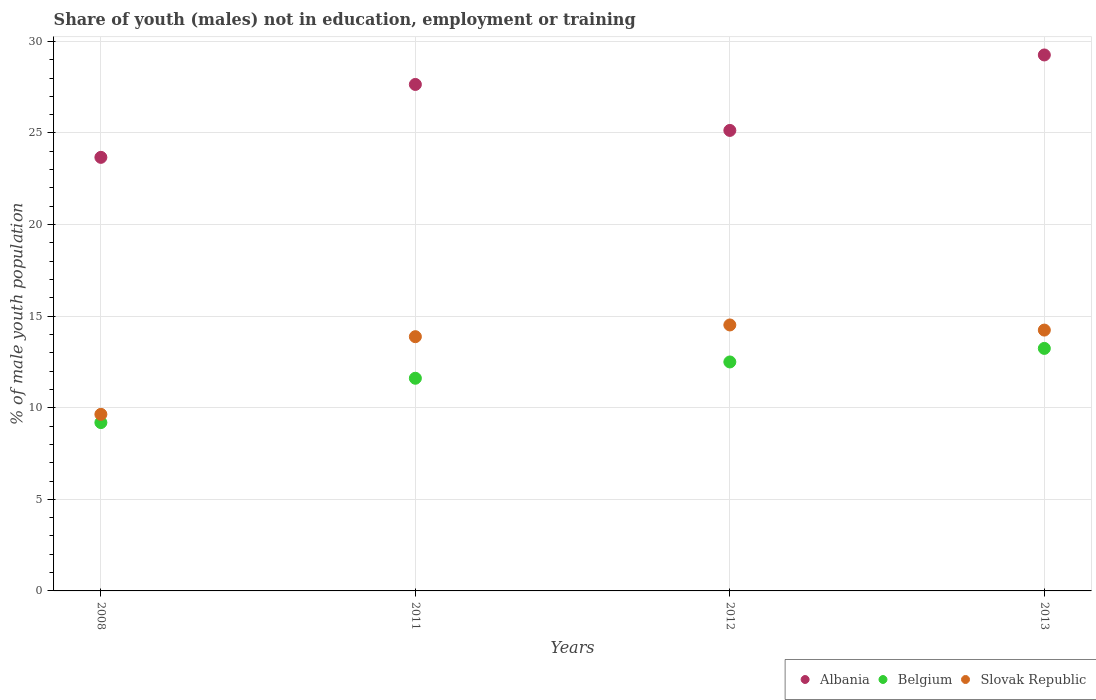How many different coloured dotlines are there?
Your answer should be compact. 3. What is the percentage of unemployed males population in in Slovak Republic in 2013?
Your response must be concise. 14.24. Across all years, what is the maximum percentage of unemployed males population in in Albania?
Keep it short and to the point. 29.26. Across all years, what is the minimum percentage of unemployed males population in in Albania?
Offer a very short reply. 23.67. In which year was the percentage of unemployed males population in in Albania maximum?
Make the answer very short. 2013. In which year was the percentage of unemployed males population in in Slovak Republic minimum?
Your answer should be compact. 2008. What is the total percentage of unemployed males population in in Belgium in the graph?
Your answer should be very brief. 46.54. What is the difference between the percentage of unemployed males population in in Slovak Republic in 2011 and that in 2012?
Make the answer very short. -0.64. What is the difference between the percentage of unemployed males population in in Slovak Republic in 2011 and the percentage of unemployed males population in in Belgium in 2013?
Your answer should be compact. 0.64. What is the average percentage of unemployed males population in in Albania per year?
Offer a terse response. 26.43. In the year 2011, what is the difference between the percentage of unemployed males population in in Albania and percentage of unemployed males population in in Slovak Republic?
Ensure brevity in your answer.  13.77. In how many years, is the percentage of unemployed males population in in Slovak Republic greater than 7 %?
Ensure brevity in your answer.  4. What is the ratio of the percentage of unemployed males population in in Belgium in 2012 to that in 2013?
Make the answer very short. 0.94. What is the difference between the highest and the second highest percentage of unemployed males population in in Belgium?
Make the answer very short. 0.74. What is the difference between the highest and the lowest percentage of unemployed males population in in Belgium?
Provide a short and direct response. 4.05. In how many years, is the percentage of unemployed males population in in Albania greater than the average percentage of unemployed males population in in Albania taken over all years?
Offer a very short reply. 2. Is it the case that in every year, the sum of the percentage of unemployed males population in in Albania and percentage of unemployed males population in in Slovak Republic  is greater than the percentage of unemployed males population in in Belgium?
Your response must be concise. Yes. Does the percentage of unemployed males population in in Albania monotonically increase over the years?
Offer a very short reply. No. How many years are there in the graph?
Keep it short and to the point. 4. Where does the legend appear in the graph?
Keep it short and to the point. Bottom right. How many legend labels are there?
Provide a succinct answer. 3. What is the title of the graph?
Your response must be concise. Share of youth (males) not in education, employment or training. Does "Mauritania" appear as one of the legend labels in the graph?
Offer a very short reply. No. What is the label or title of the Y-axis?
Your response must be concise. % of male youth population. What is the % of male youth population of Albania in 2008?
Your response must be concise. 23.67. What is the % of male youth population in Belgium in 2008?
Ensure brevity in your answer.  9.19. What is the % of male youth population of Slovak Republic in 2008?
Keep it short and to the point. 9.64. What is the % of male youth population in Albania in 2011?
Offer a very short reply. 27.65. What is the % of male youth population of Belgium in 2011?
Keep it short and to the point. 11.61. What is the % of male youth population of Slovak Republic in 2011?
Keep it short and to the point. 13.88. What is the % of male youth population in Albania in 2012?
Your answer should be compact. 25.14. What is the % of male youth population in Belgium in 2012?
Offer a terse response. 12.5. What is the % of male youth population of Slovak Republic in 2012?
Offer a very short reply. 14.52. What is the % of male youth population in Albania in 2013?
Make the answer very short. 29.26. What is the % of male youth population in Belgium in 2013?
Give a very brief answer. 13.24. What is the % of male youth population in Slovak Republic in 2013?
Your response must be concise. 14.24. Across all years, what is the maximum % of male youth population in Albania?
Keep it short and to the point. 29.26. Across all years, what is the maximum % of male youth population in Belgium?
Offer a very short reply. 13.24. Across all years, what is the maximum % of male youth population of Slovak Republic?
Your answer should be compact. 14.52. Across all years, what is the minimum % of male youth population in Albania?
Offer a very short reply. 23.67. Across all years, what is the minimum % of male youth population of Belgium?
Offer a very short reply. 9.19. Across all years, what is the minimum % of male youth population in Slovak Republic?
Offer a very short reply. 9.64. What is the total % of male youth population of Albania in the graph?
Make the answer very short. 105.72. What is the total % of male youth population in Belgium in the graph?
Offer a terse response. 46.54. What is the total % of male youth population in Slovak Republic in the graph?
Provide a short and direct response. 52.28. What is the difference between the % of male youth population in Albania in 2008 and that in 2011?
Offer a terse response. -3.98. What is the difference between the % of male youth population of Belgium in 2008 and that in 2011?
Offer a terse response. -2.42. What is the difference between the % of male youth population of Slovak Republic in 2008 and that in 2011?
Provide a succinct answer. -4.24. What is the difference between the % of male youth population in Albania in 2008 and that in 2012?
Give a very brief answer. -1.47. What is the difference between the % of male youth population of Belgium in 2008 and that in 2012?
Your answer should be very brief. -3.31. What is the difference between the % of male youth population of Slovak Republic in 2008 and that in 2012?
Your response must be concise. -4.88. What is the difference between the % of male youth population in Albania in 2008 and that in 2013?
Your answer should be compact. -5.59. What is the difference between the % of male youth population in Belgium in 2008 and that in 2013?
Give a very brief answer. -4.05. What is the difference between the % of male youth population in Slovak Republic in 2008 and that in 2013?
Provide a succinct answer. -4.6. What is the difference between the % of male youth population of Albania in 2011 and that in 2012?
Make the answer very short. 2.51. What is the difference between the % of male youth population in Belgium in 2011 and that in 2012?
Offer a terse response. -0.89. What is the difference between the % of male youth population of Slovak Republic in 2011 and that in 2012?
Make the answer very short. -0.64. What is the difference between the % of male youth population in Albania in 2011 and that in 2013?
Give a very brief answer. -1.61. What is the difference between the % of male youth population in Belgium in 2011 and that in 2013?
Your answer should be compact. -1.63. What is the difference between the % of male youth population in Slovak Republic in 2011 and that in 2013?
Your answer should be very brief. -0.36. What is the difference between the % of male youth population of Albania in 2012 and that in 2013?
Offer a very short reply. -4.12. What is the difference between the % of male youth population of Belgium in 2012 and that in 2013?
Keep it short and to the point. -0.74. What is the difference between the % of male youth population of Slovak Republic in 2012 and that in 2013?
Your response must be concise. 0.28. What is the difference between the % of male youth population in Albania in 2008 and the % of male youth population in Belgium in 2011?
Provide a short and direct response. 12.06. What is the difference between the % of male youth population of Albania in 2008 and the % of male youth population of Slovak Republic in 2011?
Offer a very short reply. 9.79. What is the difference between the % of male youth population of Belgium in 2008 and the % of male youth population of Slovak Republic in 2011?
Your answer should be very brief. -4.69. What is the difference between the % of male youth population of Albania in 2008 and the % of male youth population of Belgium in 2012?
Give a very brief answer. 11.17. What is the difference between the % of male youth population of Albania in 2008 and the % of male youth population of Slovak Republic in 2012?
Keep it short and to the point. 9.15. What is the difference between the % of male youth population of Belgium in 2008 and the % of male youth population of Slovak Republic in 2012?
Your response must be concise. -5.33. What is the difference between the % of male youth population in Albania in 2008 and the % of male youth population in Belgium in 2013?
Your response must be concise. 10.43. What is the difference between the % of male youth population of Albania in 2008 and the % of male youth population of Slovak Republic in 2013?
Your response must be concise. 9.43. What is the difference between the % of male youth population in Belgium in 2008 and the % of male youth population in Slovak Republic in 2013?
Offer a very short reply. -5.05. What is the difference between the % of male youth population in Albania in 2011 and the % of male youth population in Belgium in 2012?
Offer a very short reply. 15.15. What is the difference between the % of male youth population of Albania in 2011 and the % of male youth population of Slovak Republic in 2012?
Keep it short and to the point. 13.13. What is the difference between the % of male youth population of Belgium in 2011 and the % of male youth population of Slovak Republic in 2012?
Your response must be concise. -2.91. What is the difference between the % of male youth population in Albania in 2011 and the % of male youth population in Belgium in 2013?
Give a very brief answer. 14.41. What is the difference between the % of male youth population in Albania in 2011 and the % of male youth population in Slovak Republic in 2013?
Offer a terse response. 13.41. What is the difference between the % of male youth population of Belgium in 2011 and the % of male youth population of Slovak Republic in 2013?
Your answer should be very brief. -2.63. What is the difference between the % of male youth population in Albania in 2012 and the % of male youth population in Belgium in 2013?
Keep it short and to the point. 11.9. What is the difference between the % of male youth population of Belgium in 2012 and the % of male youth population of Slovak Republic in 2013?
Provide a succinct answer. -1.74. What is the average % of male youth population in Albania per year?
Provide a short and direct response. 26.43. What is the average % of male youth population in Belgium per year?
Your response must be concise. 11.63. What is the average % of male youth population in Slovak Republic per year?
Ensure brevity in your answer.  13.07. In the year 2008, what is the difference between the % of male youth population of Albania and % of male youth population of Belgium?
Your response must be concise. 14.48. In the year 2008, what is the difference between the % of male youth population in Albania and % of male youth population in Slovak Republic?
Your answer should be compact. 14.03. In the year 2008, what is the difference between the % of male youth population of Belgium and % of male youth population of Slovak Republic?
Ensure brevity in your answer.  -0.45. In the year 2011, what is the difference between the % of male youth population in Albania and % of male youth population in Belgium?
Your answer should be compact. 16.04. In the year 2011, what is the difference between the % of male youth population of Albania and % of male youth population of Slovak Republic?
Your answer should be very brief. 13.77. In the year 2011, what is the difference between the % of male youth population in Belgium and % of male youth population in Slovak Republic?
Keep it short and to the point. -2.27. In the year 2012, what is the difference between the % of male youth population of Albania and % of male youth population of Belgium?
Offer a terse response. 12.64. In the year 2012, what is the difference between the % of male youth population in Albania and % of male youth population in Slovak Republic?
Offer a very short reply. 10.62. In the year 2012, what is the difference between the % of male youth population of Belgium and % of male youth population of Slovak Republic?
Make the answer very short. -2.02. In the year 2013, what is the difference between the % of male youth population in Albania and % of male youth population in Belgium?
Your answer should be compact. 16.02. In the year 2013, what is the difference between the % of male youth population in Albania and % of male youth population in Slovak Republic?
Your answer should be very brief. 15.02. In the year 2013, what is the difference between the % of male youth population of Belgium and % of male youth population of Slovak Republic?
Offer a very short reply. -1. What is the ratio of the % of male youth population in Albania in 2008 to that in 2011?
Make the answer very short. 0.86. What is the ratio of the % of male youth population of Belgium in 2008 to that in 2011?
Give a very brief answer. 0.79. What is the ratio of the % of male youth population of Slovak Republic in 2008 to that in 2011?
Your answer should be very brief. 0.69. What is the ratio of the % of male youth population of Albania in 2008 to that in 2012?
Your answer should be compact. 0.94. What is the ratio of the % of male youth population of Belgium in 2008 to that in 2012?
Offer a very short reply. 0.74. What is the ratio of the % of male youth population in Slovak Republic in 2008 to that in 2012?
Offer a terse response. 0.66. What is the ratio of the % of male youth population of Albania in 2008 to that in 2013?
Ensure brevity in your answer.  0.81. What is the ratio of the % of male youth population in Belgium in 2008 to that in 2013?
Your answer should be very brief. 0.69. What is the ratio of the % of male youth population in Slovak Republic in 2008 to that in 2013?
Provide a succinct answer. 0.68. What is the ratio of the % of male youth population of Albania in 2011 to that in 2012?
Your answer should be very brief. 1.1. What is the ratio of the % of male youth population of Belgium in 2011 to that in 2012?
Your answer should be very brief. 0.93. What is the ratio of the % of male youth population of Slovak Republic in 2011 to that in 2012?
Offer a terse response. 0.96. What is the ratio of the % of male youth population in Albania in 2011 to that in 2013?
Keep it short and to the point. 0.94. What is the ratio of the % of male youth population in Belgium in 2011 to that in 2013?
Keep it short and to the point. 0.88. What is the ratio of the % of male youth population in Slovak Republic in 2011 to that in 2013?
Offer a terse response. 0.97. What is the ratio of the % of male youth population in Albania in 2012 to that in 2013?
Offer a terse response. 0.86. What is the ratio of the % of male youth population in Belgium in 2012 to that in 2013?
Offer a terse response. 0.94. What is the ratio of the % of male youth population of Slovak Republic in 2012 to that in 2013?
Offer a very short reply. 1.02. What is the difference between the highest and the second highest % of male youth population in Albania?
Your response must be concise. 1.61. What is the difference between the highest and the second highest % of male youth population in Belgium?
Make the answer very short. 0.74. What is the difference between the highest and the second highest % of male youth population in Slovak Republic?
Your answer should be compact. 0.28. What is the difference between the highest and the lowest % of male youth population in Albania?
Provide a succinct answer. 5.59. What is the difference between the highest and the lowest % of male youth population in Belgium?
Your answer should be very brief. 4.05. What is the difference between the highest and the lowest % of male youth population of Slovak Republic?
Your answer should be very brief. 4.88. 